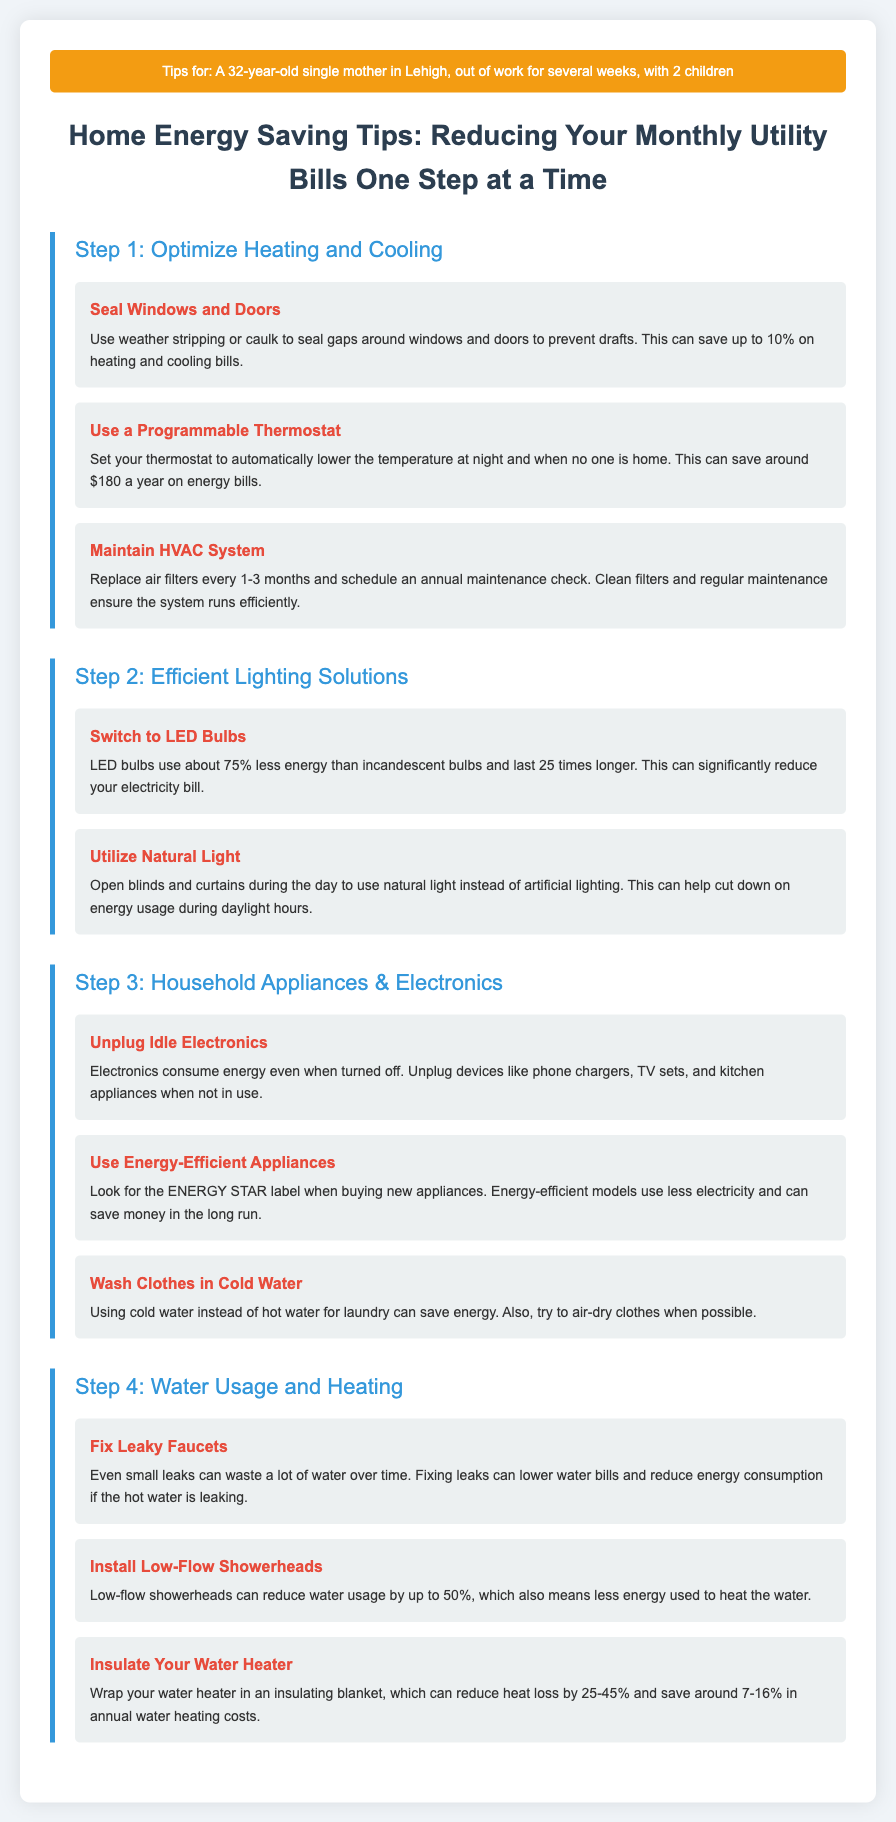What is the first step in the infographic? The first step mentioned in the infographic is about optimizing heating and cooling.
Answer: Optimize Heating and Cooling How much can sealing windows and doors save on bills? It can save up to 10% on heating and cooling bills as stated in the document.
Answer: 10% What type of light bulbs should be switched to? The document recommends switching to LED bulbs for energy savings.
Answer: LED Bulbs How much can using a programmable thermostat save annually? The infographic states that setting a programmable thermostat can save around $180 a year.
Answer: $180 What is one reason to unplug idle electronics? Idle electronics consume energy even when turned off.
Answer: Consume energy How much can low-flow showerheads reduce water usage? Low-flow showerheads can reduce water usage by up to 50%.
Answer: 50% What should you look for when buying new appliances? The document suggests looking for the ENERGY STAR label for energy-efficient appliances.
Answer: ENERGY STAR What is advised to do with leaky faucets? Fixing leaks is advised to lower water bills and reduce energy consumption.
Answer: Fixing leaks What is the result of insulating your water heater? Insulating your water heater can reduce heat loss by 25-45%.
Answer: 25-45% 